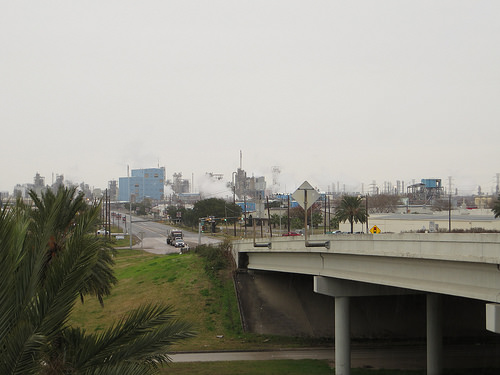<image>
Is there a road on the pillar? Yes. Looking at the image, I can see the road is positioned on top of the pillar, with the pillar providing support. 